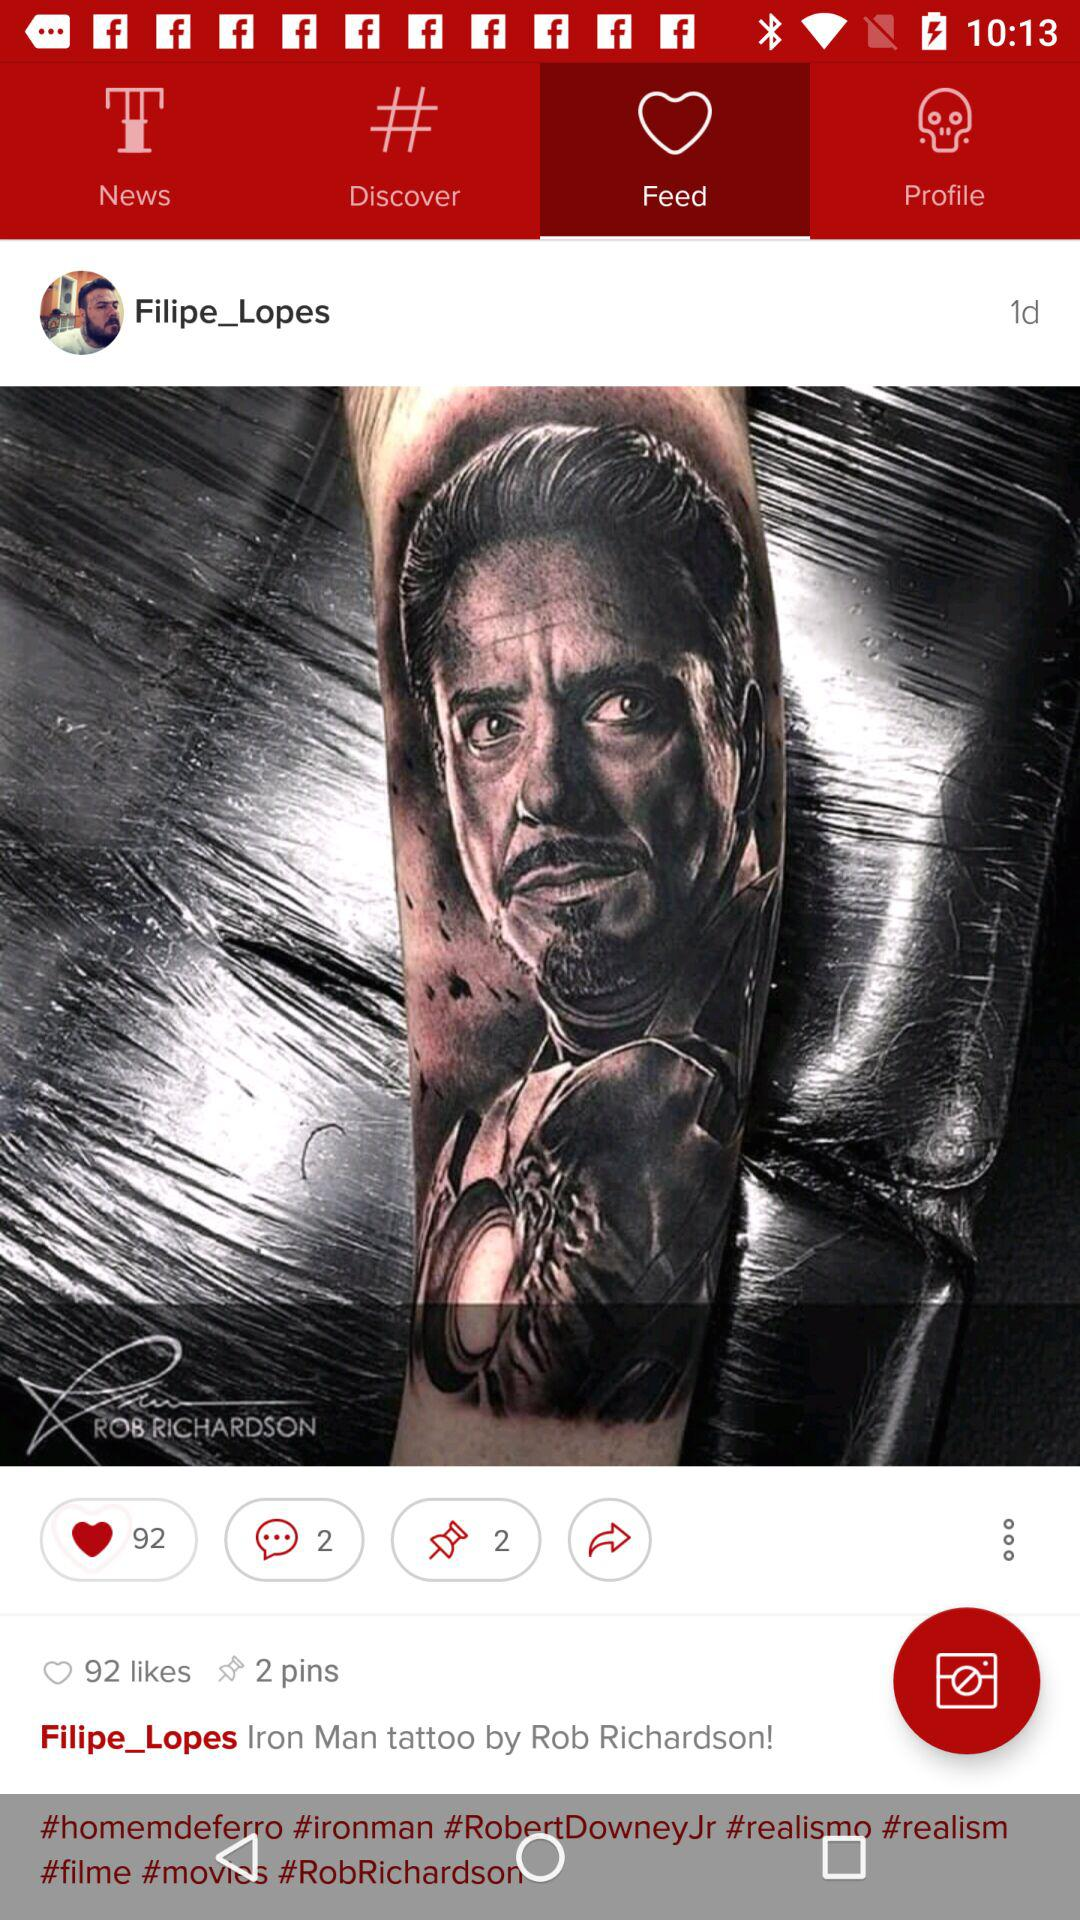How many more likes does the post have than pins?
Answer the question using a single word or phrase. 90 